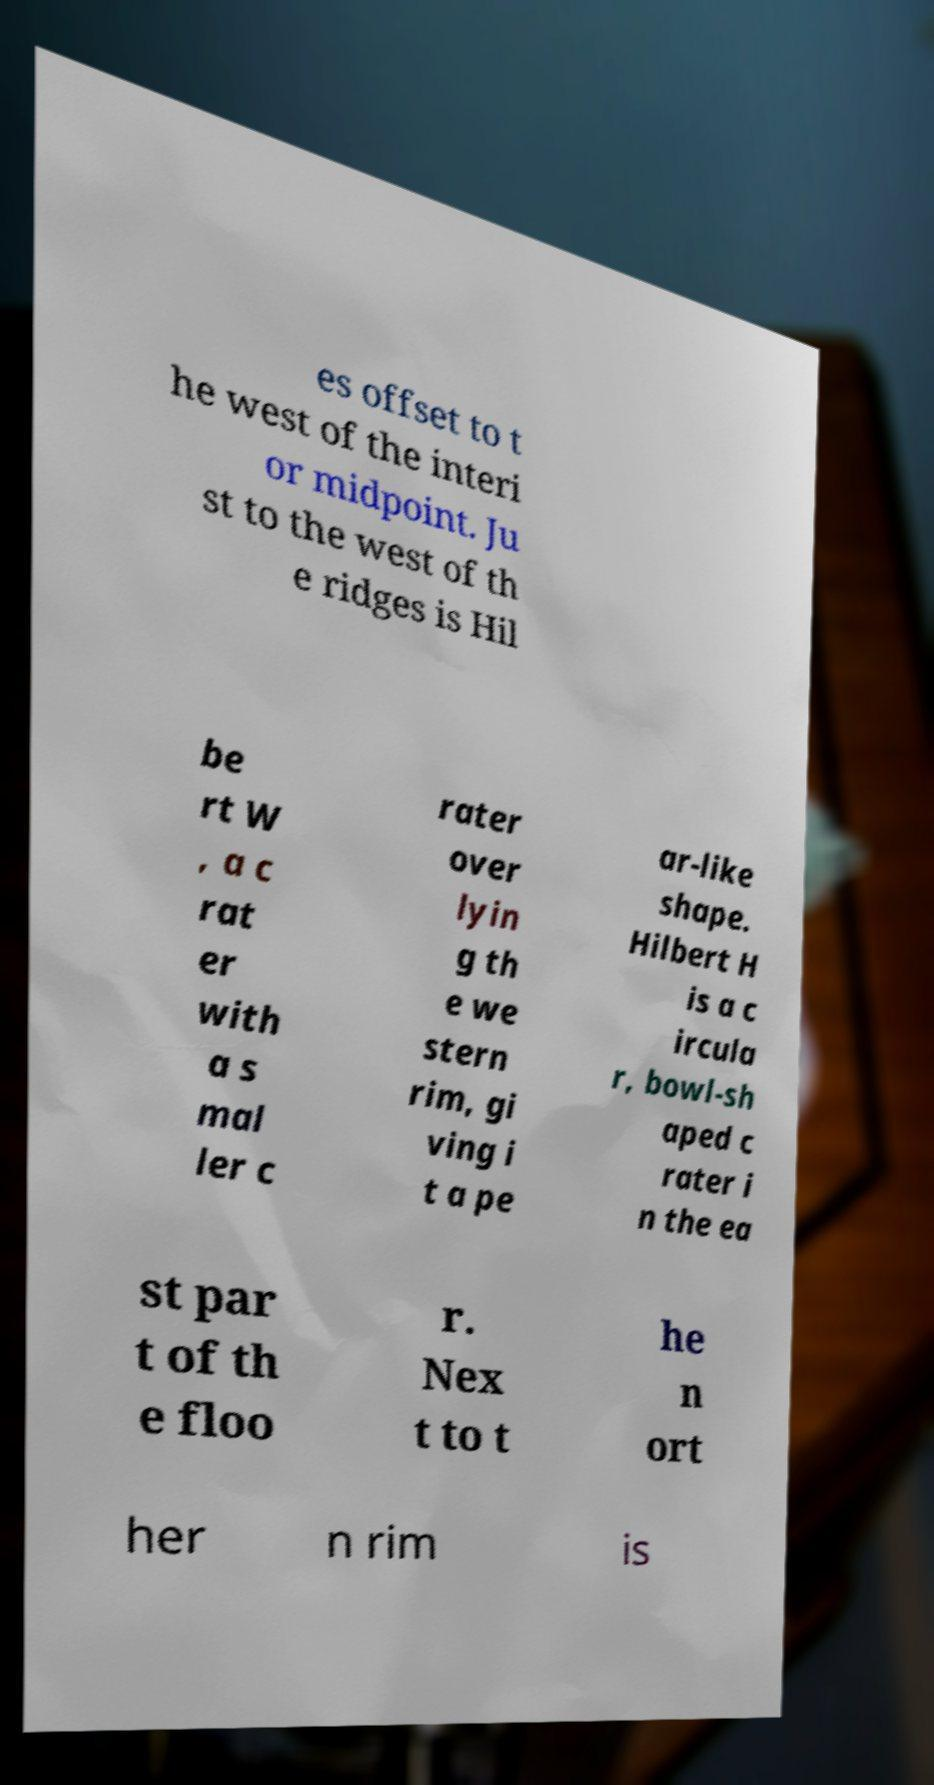Can you read and provide the text displayed in the image?This photo seems to have some interesting text. Can you extract and type it out for me? es offset to t he west of the interi or midpoint. Ju st to the west of th e ridges is Hil be rt W , a c rat er with a s mal ler c rater over lyin g th e we stern rim, gi ving i t a pe ar-like shape. Hilbert H is a c ircula r, bowl-sh aped c rater i n the ea st par t of th e floo r. Nex t to t he n ort her n rim is 